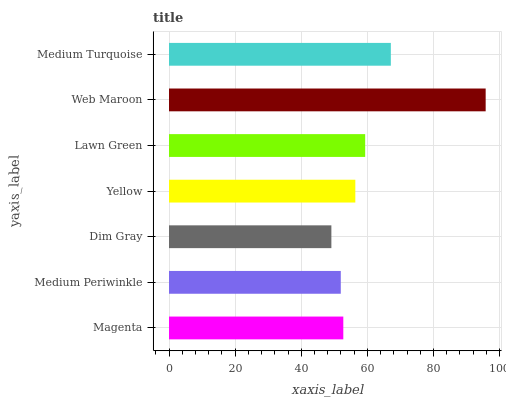Is Dim Gray the minimum?
Answer yes or no. Yes. Is Web Maroon the maximum?
Answer yes or no. Yes. Is Medium Periwinkle the minimum?
Answer yes or no. No. Is Medium Periwinkle the maximum?
Answer yes or no. No. Is Magenta greater than Medium Periwinkle?
Answer yes or no. Yes. Is Medium Periwinkle less than Magenta?
Answer yes or no. Yes. Is Medium Periwinkle greater than Magenta?
Answer yes or no. No. Is Magenta less than Medium Periwinkle?
Answer yes or no. No. Is Yellow the high median?
Answer yes or no. Yes. Is Yellow the low median?
Answer yes or no. Yes. Is Medium Turquoise the high median?
Answer yes or no. No. Is Lawn Green the low median?
Answer yes or no. No. 